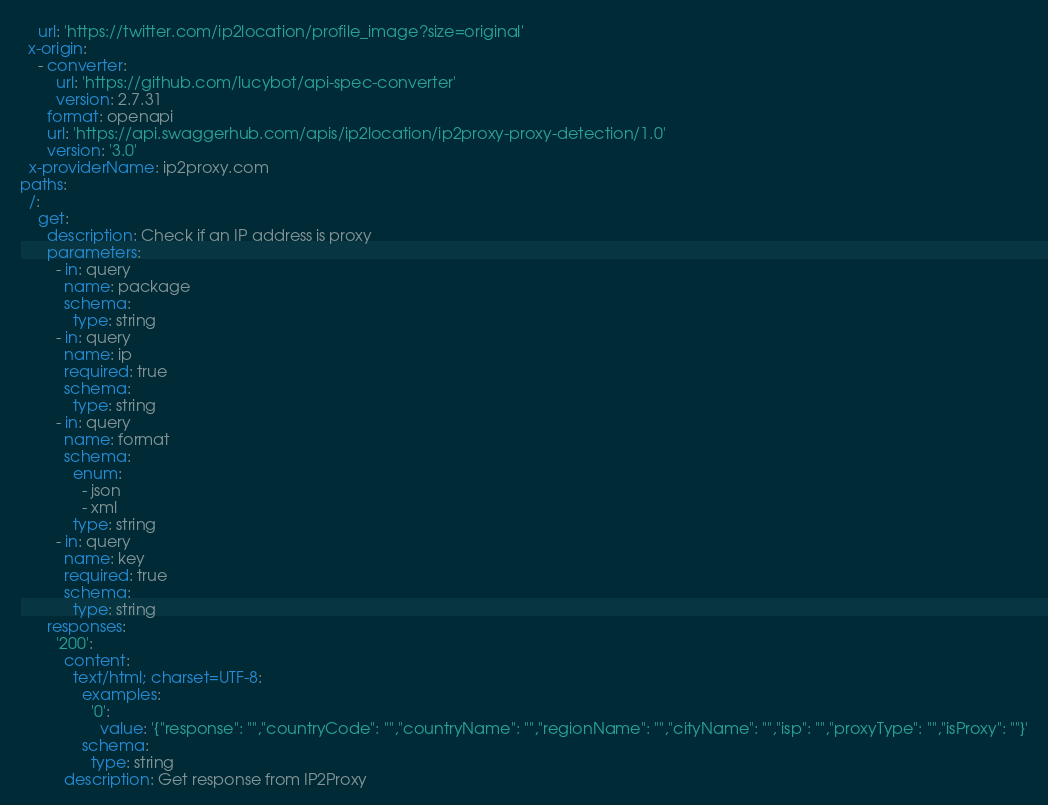Convert code to text. <code><loc_0><loc_0><loc_500><loc_500><_YAML_>    url: 'https://twitter.com/ip2location/profile_image?size=original'
  x-origin:
    - converter:
        url: 'https://github.com/lucybot/api-spec-converter'
        version: 2.7.31
      format: openapi
      url: 'https://api.swaggerhub.com/apis/ip2location/ip2proxy-proxy-detection/1.0'
      version: '3.0'
  x-providerName: ip2proxy.com
paths:
  /:
    get:
      description: Check if an IP address is proxy
      parameters:
        - in: query
          name: package
          schema:
            type: string
        - in: query
          name: ip
          required: true
          schema:
            type: string
        - in: query
          name: format
          schema:
            enum:
              - json
              - xml
            type: string
        - in: query
          name: key
          required: true
          schema:
            type: string
      responses:
        '200':
          content:
            text/html; charset=UTF-8:
              examples:
                '0':
                  value: '{"response": "","countryCode": "","countryName": "","regionName": "","cityName": "","isp": "","proxyType": "","isProxy": ""}'
              schema:
                type: string
          description: Get response from IP2Proxy
</code> 